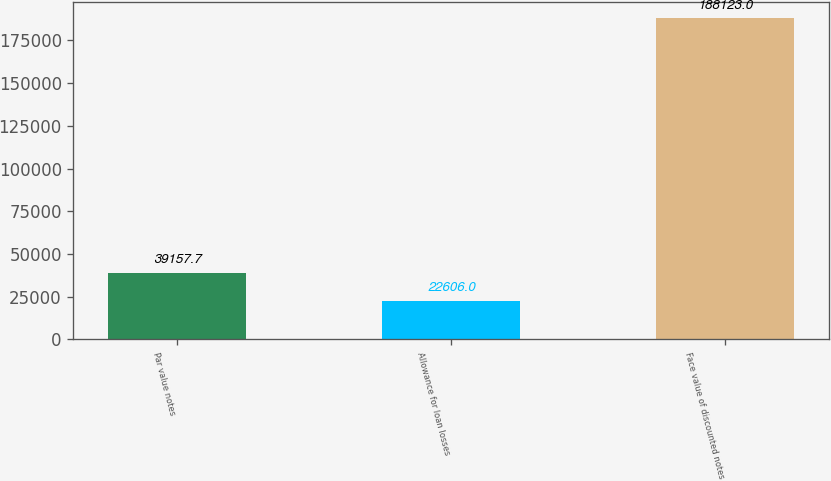Convert chart. <chart><loc_0><loc_0><loc_500><loc_500><bar_chart><fcel>Par value notes<fcel>Allowance for loan losses<fcel>Face value of discounted notes<nl><fcel>39157.7<fcel>22606<fcel>188123<nl></chart> 